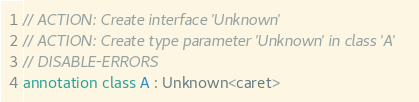Convert code to text. <code><loc_0><loc_0><loc_500><loc_500><_Kotlin_>// ACTION: Create interface 'Unknown'
// ACTION: Create type parameter 'Unknown' in class 'A'
// DISABLE-ERRORS
annotation class A : Unknown<caret></code> 